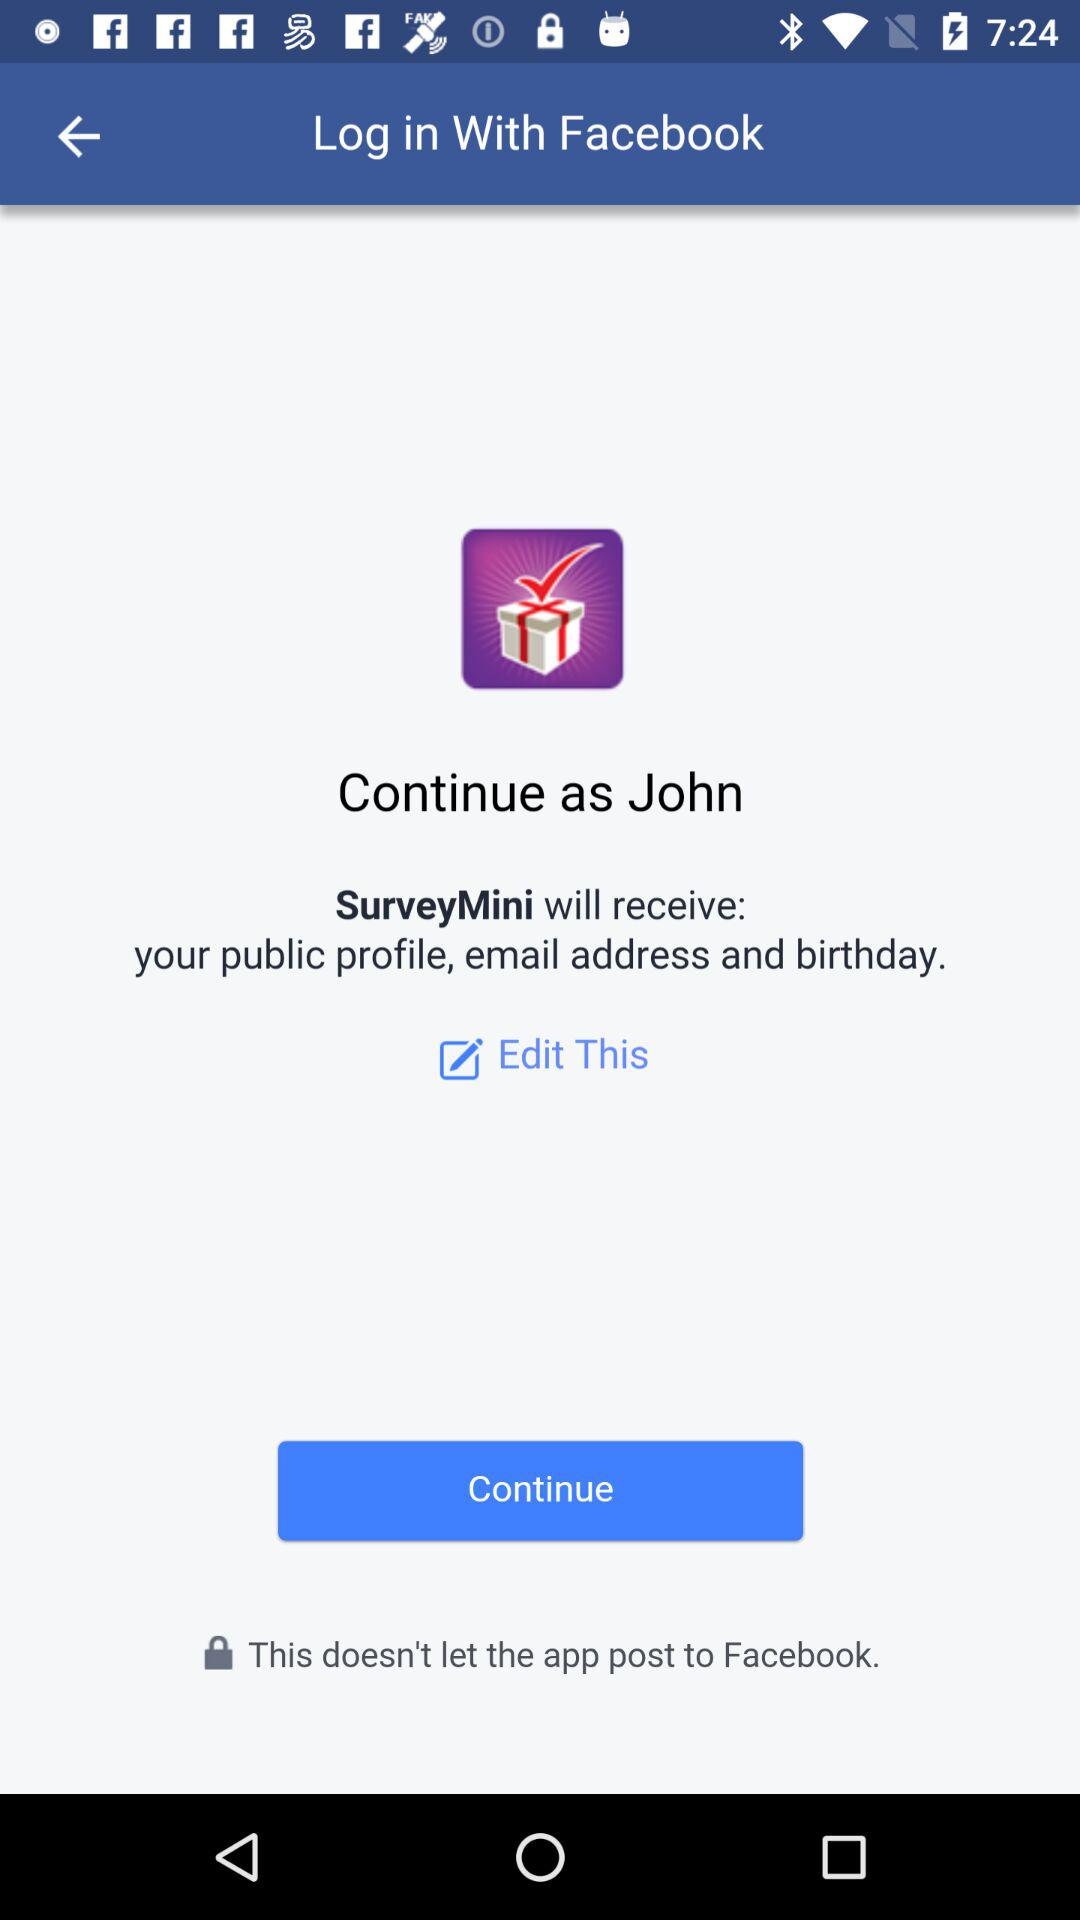What application will receive email address? The application is "SurveyMini". 